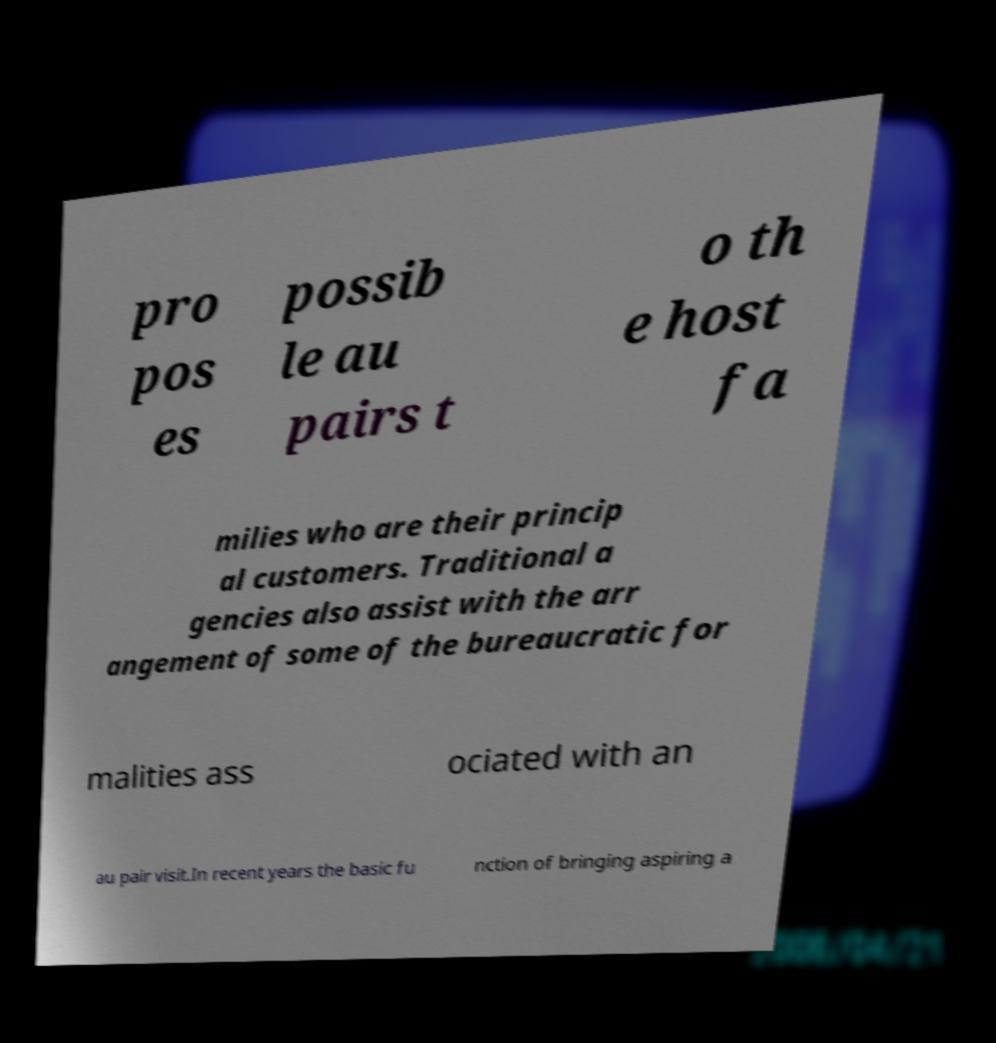Could you extract and type out the text from this image? pro pos es possib le au pairs t o th e host fa milies who are their princip al customers. Traditional a gencies also assist with the arr angement of some of the bureaucratic for malities ass ociated with an au pair visit.In recent years the basic fu nction of bringing aspiring a 